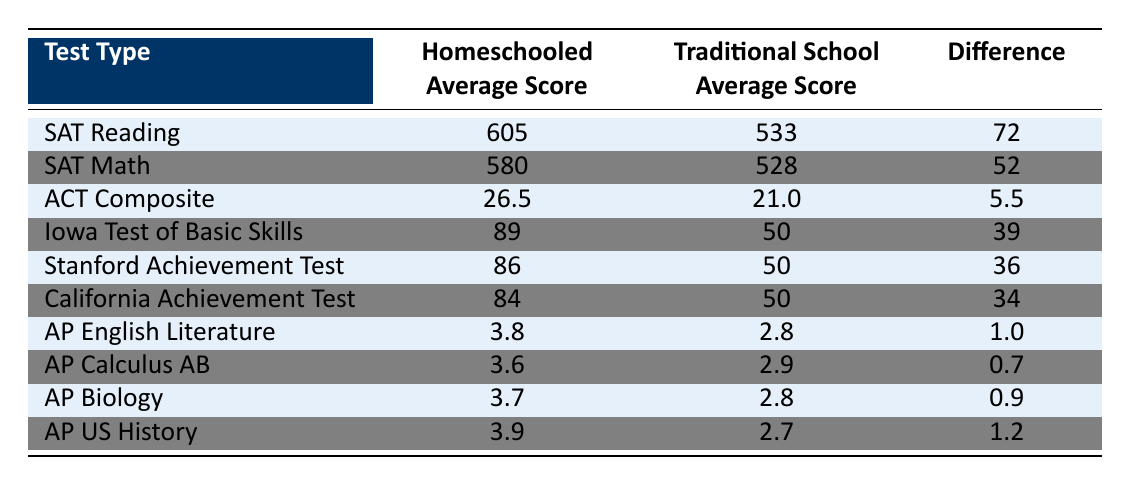What is the average score of homeschooled students on the SAT Reading test? According to the table, the average score of homeschooled students on the SAT Reading test is 605.
Answer: 605 What is the difference in average scores for the ACT Composite between homeschooled and traditionally schooled students? The difference in average scores for the ACT Composite is calculated by subtracting the traditional school average score (21.0) from the homeschooled average score (26.5), resulting in a difference of 5.5.
Answer: 5.5 Is the average score for homeschooled students higher for the SAT Math test compared to the Traditional School average? Yes, the average score for homeschooled students in SAT Math (580) is higher than the traditional school average (528), resulting in a difference of 52.
Answer: Yes What is the average score difference for the Stanford Achievement Test compared to the ACT Composite? The average score difference for the Stanford Achievement Test is 36, while for the ACT Composite it is 5.5. To find the difference between these two differences, we subtract 5.5 from 36, resulting in a difference of 30.5.
Answer: 30.5 What is the highest average score achieved by homeschooled students in the table? By examining the column for homeschooled average scores, we find that the highest score is 605 for the SAT Reading test.
Answer: 605 Is it true that homeschooled students achieved an average score of 3.8 in AP English Literature? Yes, it is true; the table shows that homeschooled students have an average score of 3.8 in AP English Literature.
Answer: Yes What is the combined average score of homeschooled students across all AP subjects listed? To find the combined average of the AP subjects, we add the average scores for AP English Literature (3.8), AP Calculus AB (3.6), AP Biology (3.7), and AP US History (3.9), which sums to 15. The average is calculated by dividing this sum by the number of subjects (4): 15/4 = 3.75.
Answer: 3.75 How do the average scores in the Iowa Test of Basic Skills compare to the SAT Math scores for traditionally schooled students? The average score for homeschooled students on the Iowa Test of Basic Skills is 89, while the average score for traditionally schooled students in SAT Math is 528. Thus, homeschooled students significantly outperformed, with a difference of 39 in the Iowa Test compared to SAT Math.
Answer: Homeschooled students significantly outperformed What is the average score difference for all tests combined? We can calculate the overall average score difference by adding all individual differences: 72 (SAT Reading) + 52 (SAT Math) + 5.5 (ACT Composite) + 39 (Iowa Test) + 36 (Stanford Test) + 34 (California Test) + 1.0 (AP English) + 0.7 (AP Calculus) + 0.9 (AP Biology) + 1.2 (AP US History) = 238. There are 10 tests, so the average difference is 238/10 = 23.8.
Answer: 23.8 